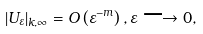<formula> <loc_0><loc_0><loc_500><loc_500>\left | U _ { \varepsilon } \right | _ { k , \infty } = O \left ( \varepsilon ^ { - m } \right ) , \varepsilon \longrightarrow 0 ,</formula> 